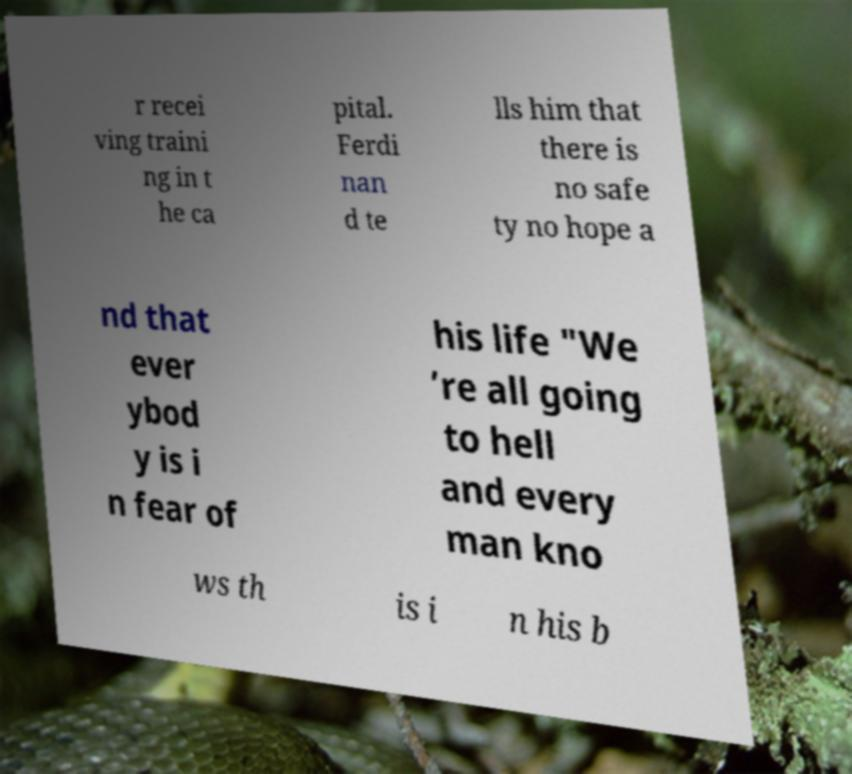Please read and relay the text visible in this image. What does it say? r recei ving traini ng in t he ca pital. Ferdi nan d te lls him that there is no safe ty no hope a nd that ever ybod y is i n fear of his life "We ’re all going to hell and every man kno ws th is i n his b 